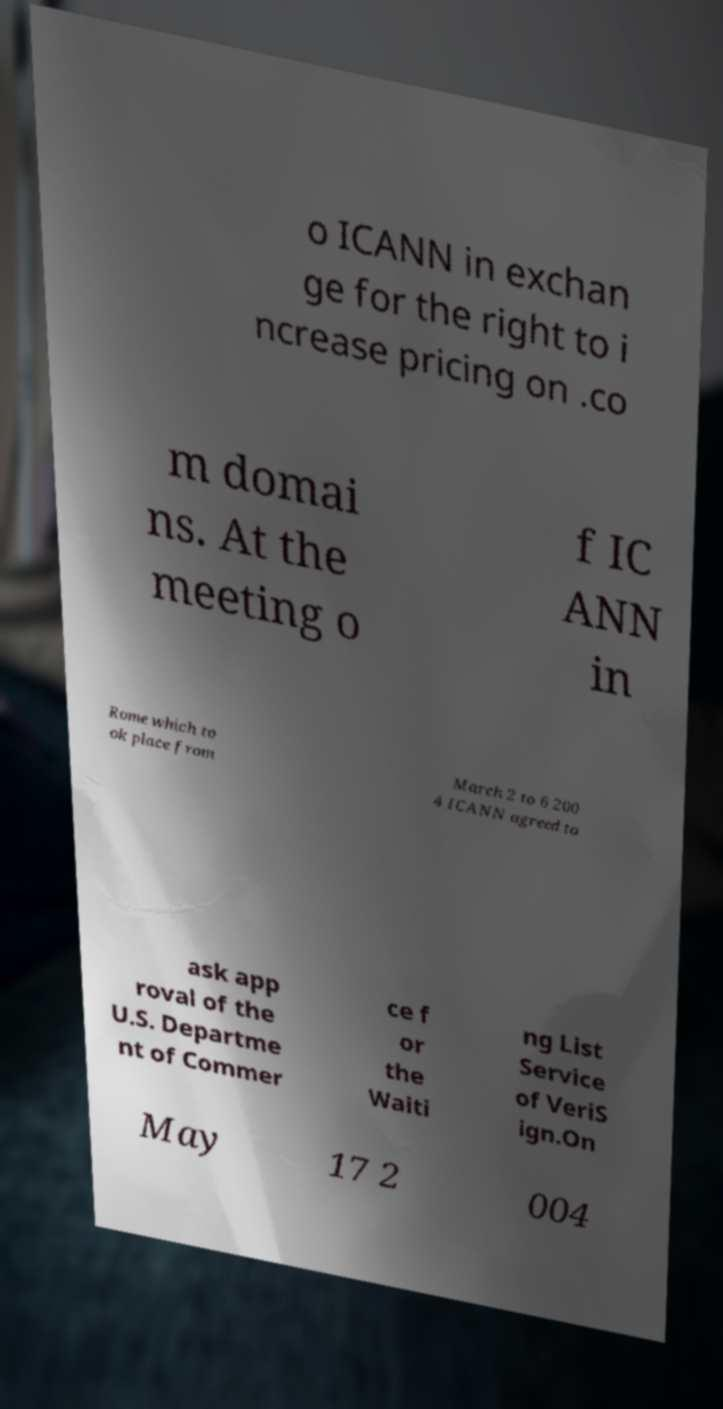For documentation purposes, I need the text within this image transcribed. Could you provide that? o ICANN in exchan ge for the right to i ncrease pricing on .co m domai ns. At the meeting o f IC ANN in Rome which to ok place from March 2 to 6 200 4 ICANN agreed to ask app roval of the U.S. Departme nt of Commer ce f or the Waiti ng List Service of VeriS ign.On May 17 2 004 